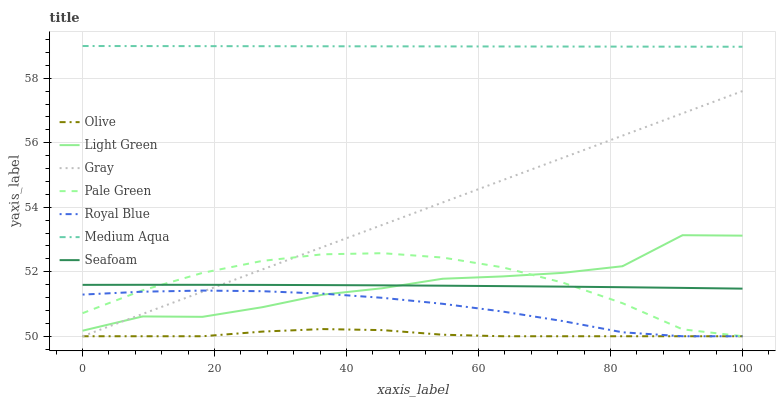Does Olive have the minimum area under the curve?
Answer yes or no. Yes. Does Medium Aqua have the maximum area under the curve?
Answer yes or no. Yes. Does Seafoam have the minimum area under the curve?
Answer yes or no. No. Does Seafoam have the maximum area under the curve?
Answer yes or no. No. Is Medium Aqua the smoothest?
Answer yes or no. Yes. Is Light Green the roughest?
Answer yes or no. Yes. Is Seafoam the smoothest?
Answer yes or no. No. Is Seafoam the roughest?
Answer yes or no. No. Does Gray have the lowest value?
Answer yes or no. Yes. Does Seafoam have the lowest value?
Answer yes or no. No. Does Medium Aqua have the highest value?
Answer yes or no. Yes. Does Seafoam have the highest value?
Answer yes or no. No. Is Olive less than Medium Aqua?
Answer yes or no. Yes. Is Medium Aqua greater than Gray?
Answer yes or no. Yes. Does Light Green intersect Seafoam?
Answer yes or no. Yes. Is Light Green less than Seafoam?
Answer yes or no. No. Is Light Green greater than Seafoam?
Answer yes or no. No. Does Olive intersect Medium Aqua?
Answer yes or no. No. 